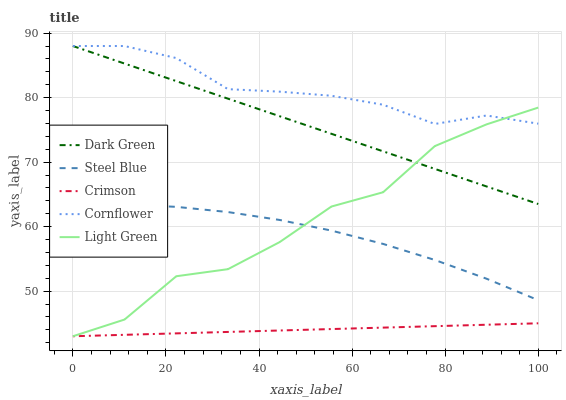Does Steel Blue have the minimum area under the curve?
Answer yes or no. No. Does Steel Blue have the maximum area under the curve?
Answer yes or no. No. Is Cornflower the smoothest?
Answer yes or no. No. Is Cornflower the roughest?
Answer yes or no. No. Does Steel Blue have the lowest value?
Answer yes or no. No. Does Steel Blue have the highest value?
Answer yes or no. No. Is Crimson less than Dark Green?
Answer yes or no. Yes. Is Dark Green greater than Steel Blue?
Answer yes or no. Yes. Does Crimson intersect Dark Green?
Answer yes or no. No. 